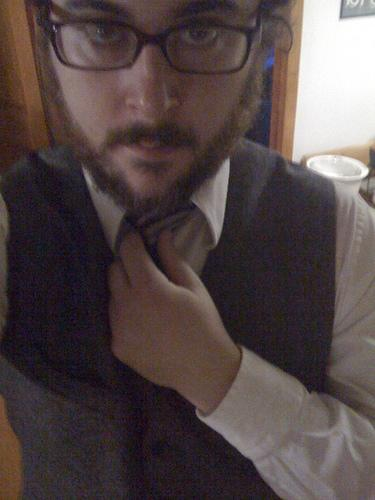What is the man adjusting? tie 